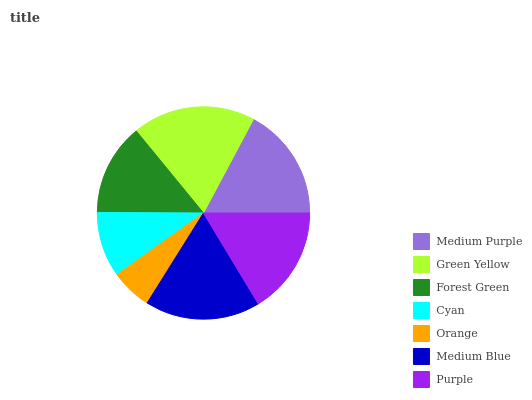Is Orange the minimum?
Answer yes or no. Yes. Is Green Yellow the maximum?
Answer yes or no. Yes. Is Forest Green the minimum?
Answer yes or no. No. Is Forest Green the maximum?
Answer yes or no. No. Is Green Yellow greater than Forest Green?
Answer yes or no. Yes. Is Forest Green less than Green Yellow?
Answer yes or no. Yes. Is Forest Green greater than Green Yellow?
Answer yes or no. No. Is Green Yellow less than Forest Green?
Answer yes or no. No. Is Purple the high median?
Answer yes or no. Yes. Is Purple the low median?
Answer yes or no. Yes. Is Medium Purple the high median?
Answer yes or no. No. Is Green Yellow the low median?
Answer yes or no. No. 